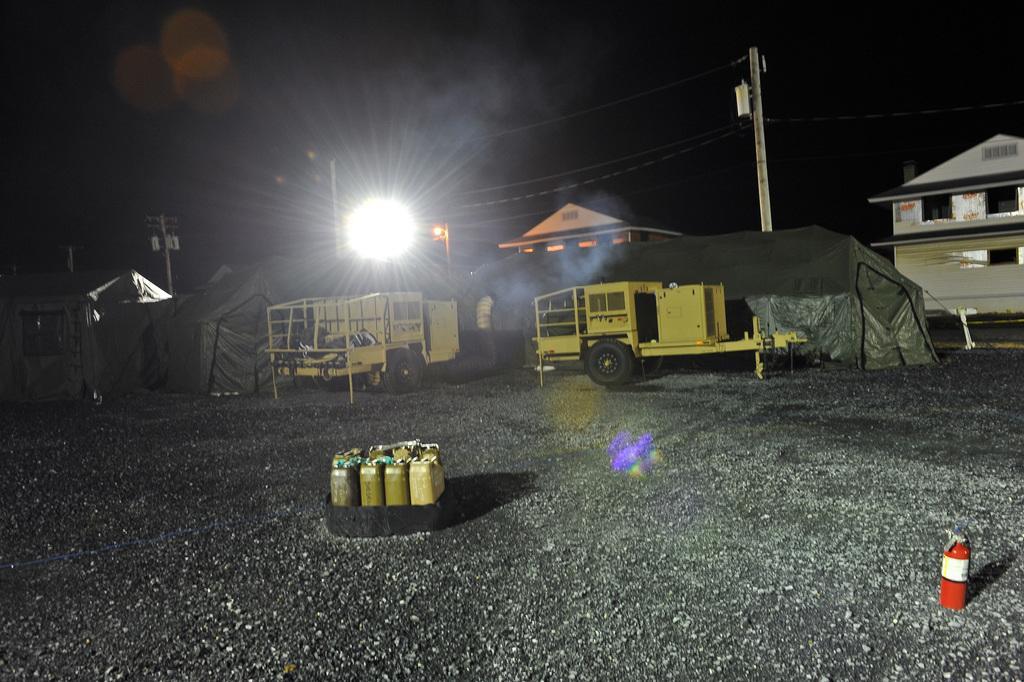Can you describe this image briefly? In this image in the center there are some vehicles, tents, buildings, pole, wires and lights. At the bottom there is walkway, and in the center there are some cans and on the right side of the image there is one cylinder. 